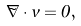Convert formula to latex. <formula><loc_0><loc_0><loc_500><loc_500>\vec { \nabla } \cdot { v } = 0 ,</formula> 